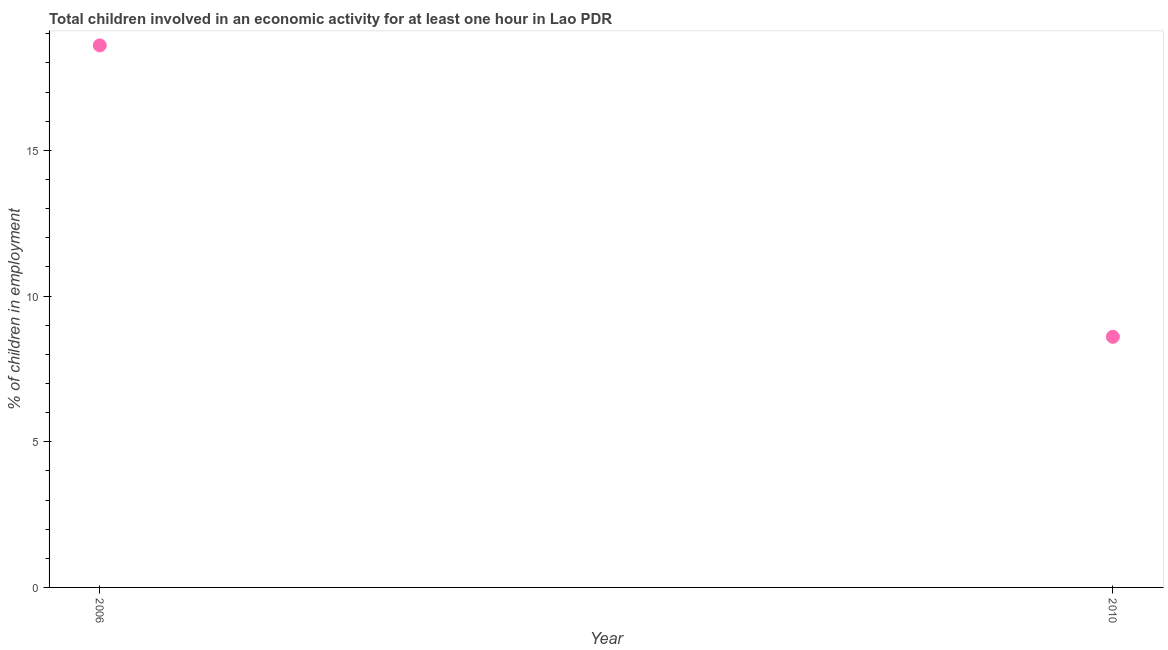What is the percentage of children in employment in 2006?
Your answer should be very brief. 18.6. Across all years, what is the maximum percentage of children in employment?
Your answer should be compact. 18.6. Across all years, what is the minimum percentage of children in employment?
Your answer should be very brief. 8.6. In which year was the percentage of children in employment maximum?
Offer a terse response. 2006. What is the sum of the percentage of children in employment?
Your response must be concise. 27.2. What is the difference between the percentage of children in employment in 2006 and 2010?
Your answer should be compact. 10. What is the average percentage of children in employment per year?
Offer a terse response. 13.6. What is the median percentage of children in employment?
Your answer should be very brief. 13.6. In how many years, is the percentage of children in employment greater than 6 %?
Your response must be concise. 2. Do a majority of the years between 2006 and 2010 (inclusive) have percentage of children in employment greater than 3 %?
Provide a short and direct response. Yes. What is the ratio of the percentage of children in employment in 2006 to that in 2010?
Offer a terse response. 2.16. Is the percentage of children in employment in 2006 less than that in 2010?
Your answer should be compact. No. Does the percentage of children in employment monotonically increase over the years?
Keep it short and to the point. No. What is the difference between two consecutive major ticks on the Y-axis?
Provide a succinct answer. 5. Does the graph contain any zero values?
Provide a succinct answer. No. Does the graph contain grids?
Keep it short and to the point. No. What is the title of the graph?
Your answer should be compact. Total children involved in an economic activity for at least one hour in Lao PDR. What is the label or title of the Y-axis?
Offer a very short reply. % of children in employment. What is the % of children in employment in 2006?
Make the answer very short. 18.6. What is the ratio of the % of children in employment in 2006 to that in 2010?
Keep it short and to the point. 2.16. 